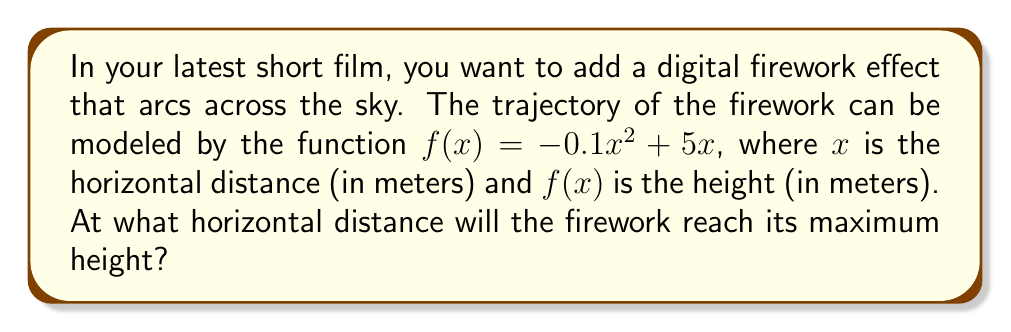Give your solution to this math problem. Let's approach this step-by-step:

1) The function $f(x) = -0.1x^2 + 5x$ is a quadratic function, which forms a parabola.

2) To find the maximum height, we need to find the vertex of this parabola.

3) For a quadratic function in the form $f(x) = ax^2 + bx + c$, the x-coordinate of the vertex is given by $x = -\frac{b}{2a}$.

4) In our case, $a = -0.1$ and $b = 5$.

5) Substituting these values:

   $x = -\frac{5}{2(-0.1)} = -\frac{5}{-0.2} = 25$

6) Therefore, the firework will reach its maximum height when $x = 25$ meters.

7) To verify, we can calculate $f'(x)$:
   
   $f'(x) = -0.2x + 5$

8) Setting $f'(x) = 0$:
   
   $-0.2x + 5 = 0$
   $-0.2x = -5$
   $x = 25$

This confirms our result.
Answer: 25 meters 